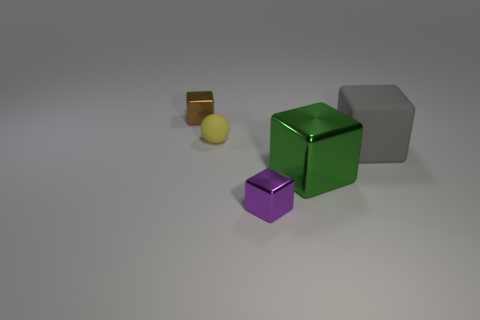How many green things are the same material as the large gray thing?
Your answer should be very brief. 0. There is a tiny object that is the same material as the large gray cube; what color is it?
Give a very brief answer. Yellow. What material is the tiny block to the right of the brown metal block?
Your answer should be compact. Metal. Are there an equal number of brown metal objects to the right of the large green metallic object and small brown shiny blocks?
Provide a short and direct response. No. What number of other tiny matte balls have the same color as the ball?
Give a very brief answer. 0. What color is the other big metal object that is the same shape as the brown metallic object?
Offer a terse response. Green. Do the matte block and the brown cube have the same size?
Your answer should be compact. No. Are there the same number of tiny yellow rubber objects on the left side of the tiny yellow matte sphere and green metal objects that are in front of the gray thing?
Make the answer very short. No. Are any purple metal cylinders visible?
Your response must be concise. No. What is the size of the purple object that is the same shape as the tiny brown metal object?
Keep it short and to the point. Small. 